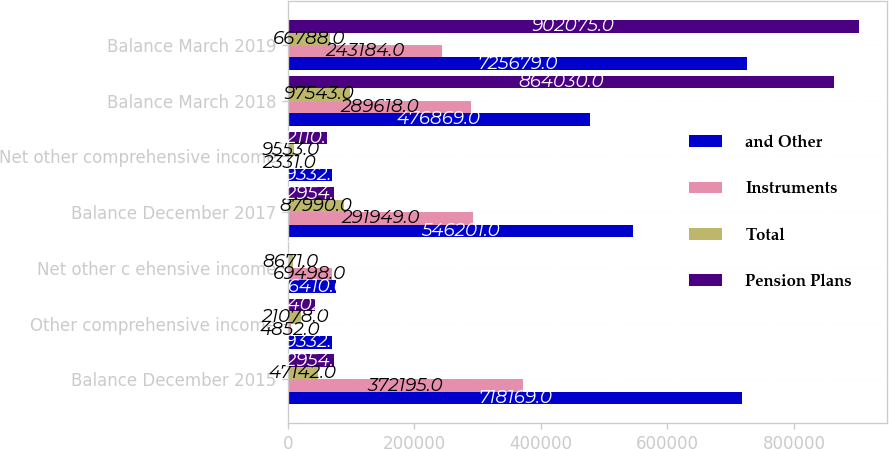Convert chart. <chart><loc_0><loc_0><loc_500><loc_500><stacked_bar_chart><ecel><fcel>Balance December 2015<fcel>Other comprehensive income<fcel>Net other c ehensive income<fcel>Balance December 2017<fcel>Net other comprehensive income<fcel>Balance March 2018<fcel>Balance March 2019<nl><fcel>and Other<fcel>718169<fcel>69332<fcel>76410<fcel>546201<fcel>69332<fcel>476869<fcel>725679<nl><fcel>Instruments<fcel>372195<fcel>4852<fcel>69498<fcel>291949<fcel>2331<fcel>289618<fcel>243184<nl><fcel>Total<fcel>47142<fcel>21078<fcel>8671<fcel>87990<fcel>9553<fcel>97543<fcel>66788<nl><fcel>Pension Plans<fcel>72954<fcel>43402<fcel>1759<fcel>72954<fcel>62110<fcel>864030<fcel>902075<nl></chart> 